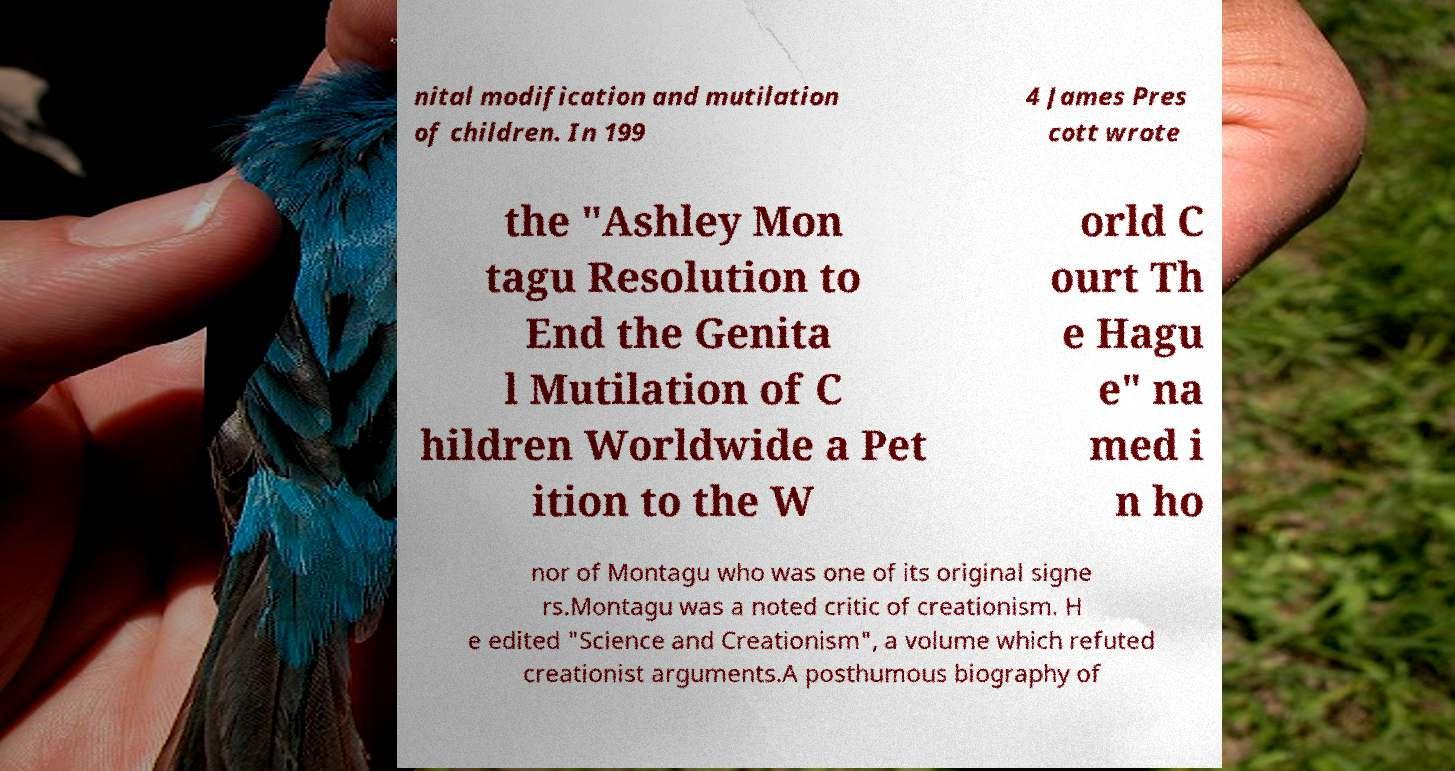Please identify and transcribe the text found in this image. nital modification and mutilation of children. In 199 4 James Pres cott wrote the "Ashley Mon tagu Resolution to End the Genita l Mutilation of C hildren Worldwide a Pet ition to the W orld C ourt Th e Hagu e" na med i n ho nor of Montagu who was one of its original signe rs.Montagu was a noted critic of creationism. H e edited "Science and Creationism", a volume which refuted creationist arguments.A posthumous biography of 